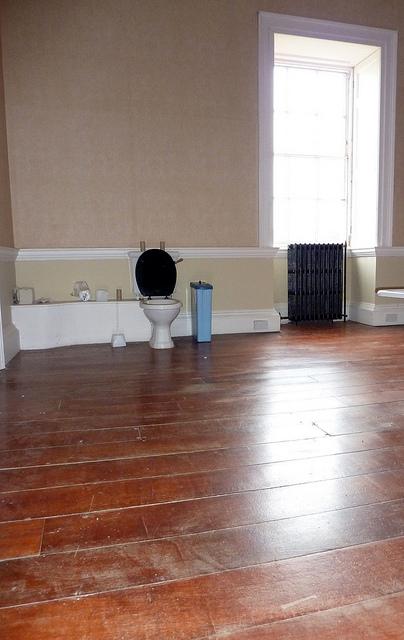What is under the window?
Quick response, please. Radiator. What type of floor is this?
Keep it brief. Wood. Where does the toilet belong?
Quick response, please. Bathroom. 